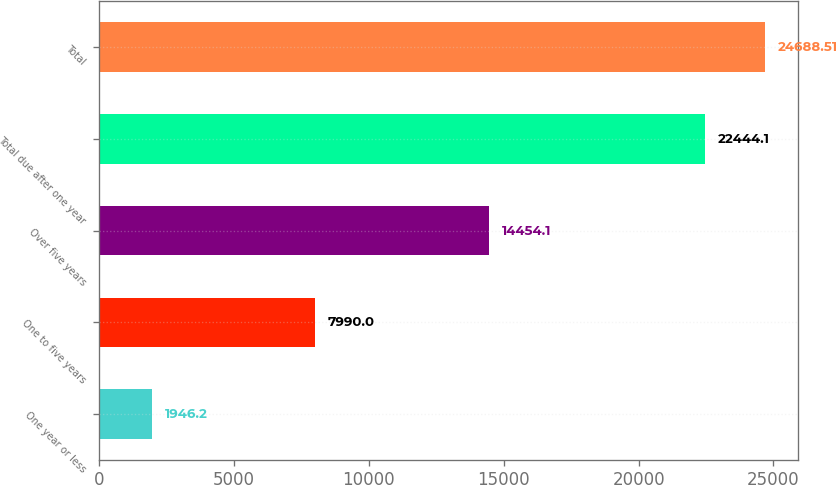Convert chart to OTSL. <chart><loc_0><loc_0><loc_500><loc_500><bar_chart><fcel>One year or less<fcel>One to five years<fcel>Over five years<fcel>Total due after one year<fcel>Total<nl><fcel>1946.2<fcel>7990<fcel>14454.1<fcel>22444.1<fcel>24688.5<nl></chart> 